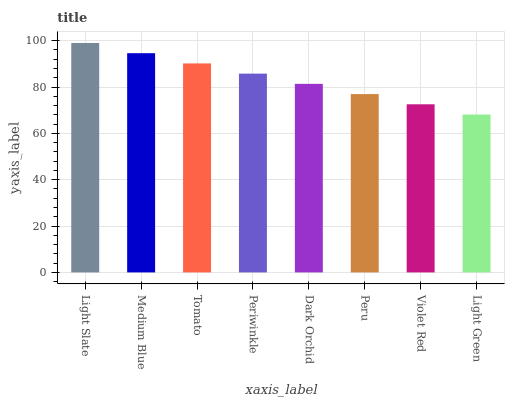Is Light Green the minimum?
Answer yes or no. Yes. Is Light Slate the maximum?
Answer yes or no. Yes. Is Medium Blue the minimum?
Answer yes or no. No. Is Medium Blue the maximum?
Answer yes or no. No. Is Light Slate greater than Medium Blue?
Answer yes or no. Yes. Is Medium Blue less than Light Slate?
Answer yes or no. Yes. Is Medium Blue greater than Light Slate?
Answer yes or no. No. Is Light Slate less than Medium Blue?
Answer yes or no. No. Is Periwinkle the high median?
Answer yes or no. Yes. Is Dark Orchid the low median?
Answer yes or no. Yes. Is Light Slate the high median?
Answer yes or no. No. Is Medium Blue the low median?
Answer yes or no. No. 